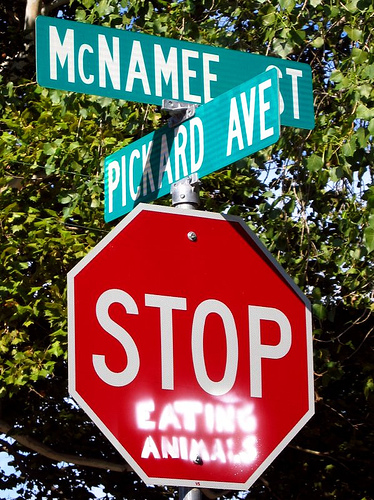Read all the text in this image. McNAMEE ST PICKARD AVE STOP EATING ANIMALS 